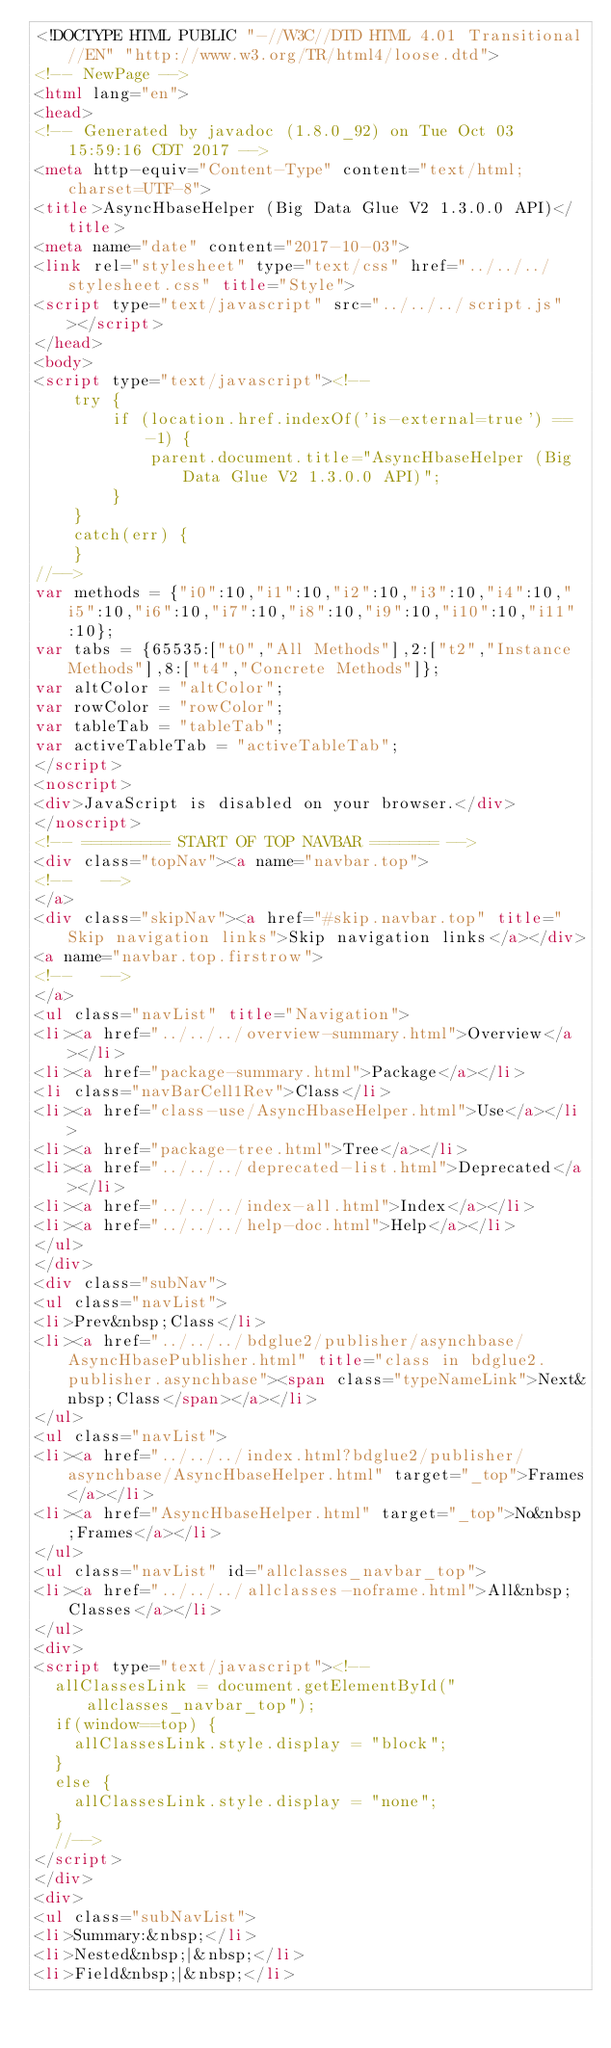Convert code to text. <code><loc_0><loc_0><loc_500><loc_500><_HTML_><!DOCTYPE HTML PUBLIC "-//W3C//DTD HTML 4.01 Transitional//EN" "http://www.w3.org/TR/html4/loose.dtd">
<!-- NewPage -->
<html lang="en">
<head>
<!-- Generated by javadoc (1.8.0_92) on Tue Oct 03 15:59:16 CDT 2017 -->
<meta http-equiv="Content-Type" content="text/html; charset=UTF-8">
<title>AsyncHbaseHelper (Big Data Glue V2 1.3.0.0 API)</title>
<meta name="date" content="2017-10-03">
<link rel="stylesheet" type="text/css" href="../../../stylesheet.css" title="Style">
<script type="text/javascript" src="../../../script.js"></script>
</head>
<body>
<script type="text/javascript"><!--
    try {
        if (location.href.indexOf('is-external=true') == -1) {
            parent.document.title="AsyncHbaseHelper (Big Data Glue V2 1.3.0.0 API)";
        }
    }
    catch(err) {
    }
//-->
var methods = {"i0":10,"i1":10,"i2":10,"i3":10,"i4":10,"i5":10,"i6":10,"i7":10,"i8":10,"i9":10,"i10":10,"i11":10};
var tabs = {65535:["t0","All Methods"],2:["t2","Instance Methods"],8:["t4","Concrete Methods"]};
var altColor = "altColor";
var rowColor = "rowColor";
var tableTab = "tableTab";
var activeTableTab = "activeTableTab";
</script>
<noscript>
<div>JavaScript is disabled on your browser.</div>
</noscript>
<!-- ========= START OF TOP NAVBAR ======= -->
<div class="topNav"><a name="navbar.top">
<!--   -->
</a>
<div class="skipNav"><a href="#skip.navbar.top" title="Skip navigation links">Skip navigation links</a></div>
<a name="navbar.top.firstrow">
<!--   -->
</a>
<ul class="navList" title="Navigation">
<li><a href="../../../overview-summary.html">Overview</a></li>
<li><a href="package-summary.html">Package</a></li>
<li class="navBarCell1Rev">Class</li>
<li><a href="class-use/AsyncHbaseHelper.html">Use</a></li>
<li><a href="package-tree.html">Tree</a></li>
<li><a href="../../../deprecated-list.html">Deprecated</a></li>
<li><a href="../../../index-all.html">Index</a></li>
<li><a href="../../../help-doc.html">Help</a></li>
</ul>
</div>
<div class="subNav">
<ul class="navList">
<li>Prev&nbsp;Class</li>
<li><a href="../../../bdglue2/publisher/asynchbase/AsyncHbasePublisher.html" title="class in bdglue2.publisher.asynchbase"><span class="typeNameLink">Next&nbsp;Class</span></a></li>
</ul>
<ul class="navList">
<li><a href="../../../index.html?bdglue2/publisher/asynchbase/AsyncHbaseHelper.html" target="_top">Frames</a></li>
<li><a href="AsyncHbaseHelper.html" target="_top">No&nbsp;Frames</a></li>
</ul>
<ul class="navList" id="allclasses_navbar_top">
<li><a href="../../../allclasses-noframe.html">All&nbsp;Classes</a></li>
</ul>
<div>
<script type="text/javascript"><!--
  allClassesLink = document.getElementById("allclasses_navbar_top");
  if(window==top) {
    allClassesLink.style.display = "block";
  }
  else {
    allClassesLink.style.display = "none";
  }
  //-->
</script>
</div>
<div>
<ul class="subNavList">
<li>Summary:&nbsp;</li>
<li>Nested&nbsp;|&nbsp;</li>
<li>Field&nbsp;|&nbsp;</li></code> 